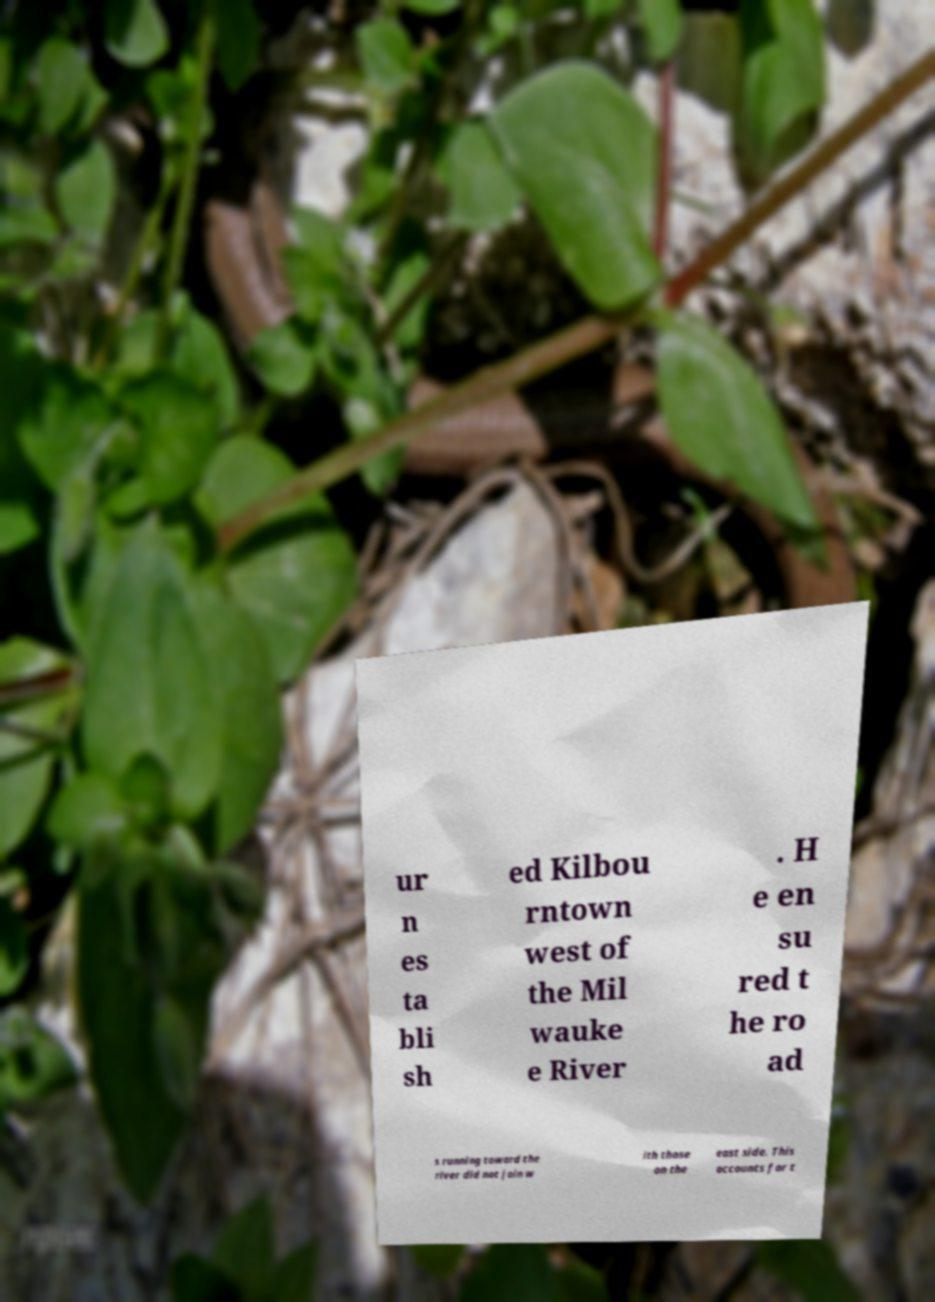Please read and relay the text visible in this image. What does it say? ur n es ta bli sh ed Kilbou rntown west of the Mil wauke e River . H e en su red t he ro ad s running toward the river did not join w ith those on the east side. This accounts for t 